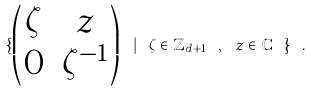<formula> <loc_0><loc_0><loc_500><loc_500>\{ \begin{pmatrix} \zeta & z \\ 0 & \zeta ^ { - 1 } \end{pmatrix} \ | \ \zeta \in \mathbb { Z } _ { d + 1 } \ , \ z \in \mathbb { C } \ \} \ .</formula> 